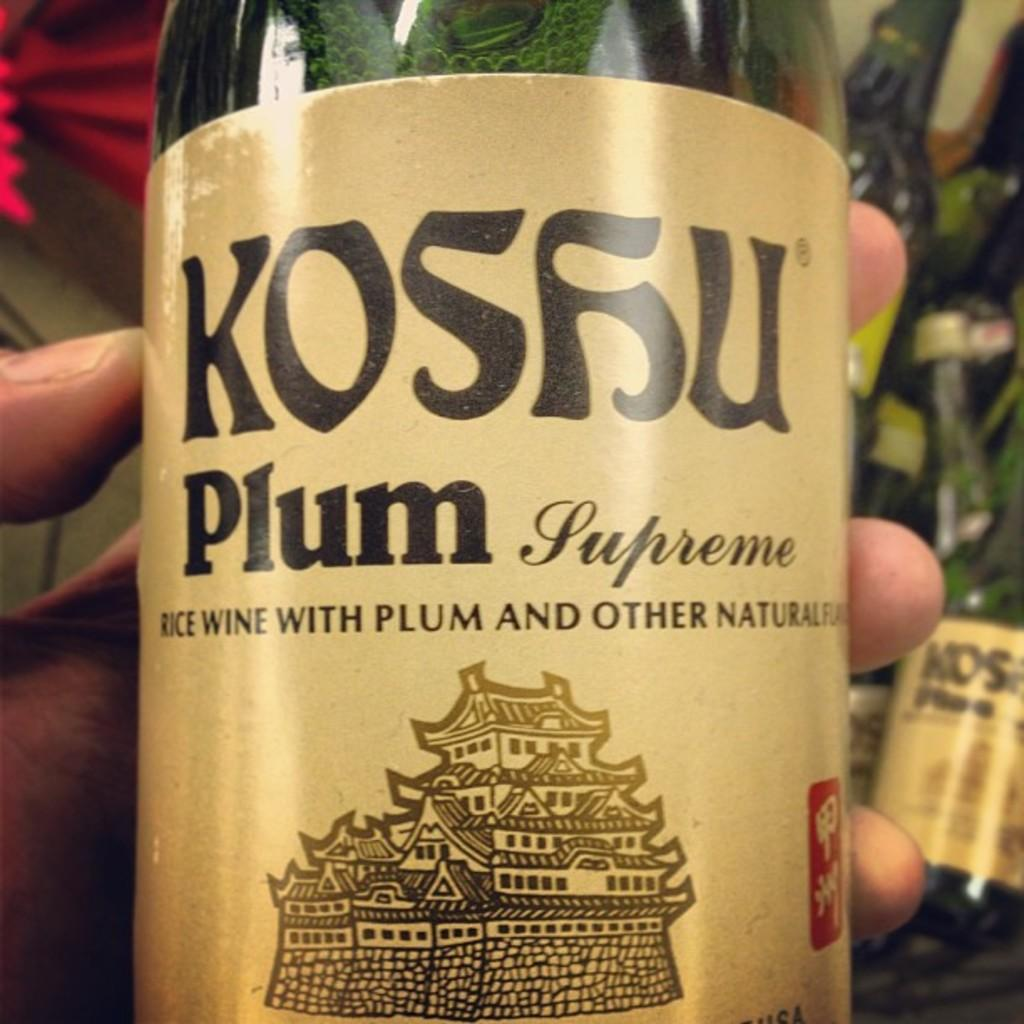What color is the bottle that is visible in the image? The bottle is yellow in the image. Where is the bottle located in the image? The bottle is in the middle of the image. Who is holding the bottle in the image? There is a person holding the bottle in the image. What type of books can be found in the library depicted in the image? There is no library present in the image; it features a yellow bottle and a person holding it. 